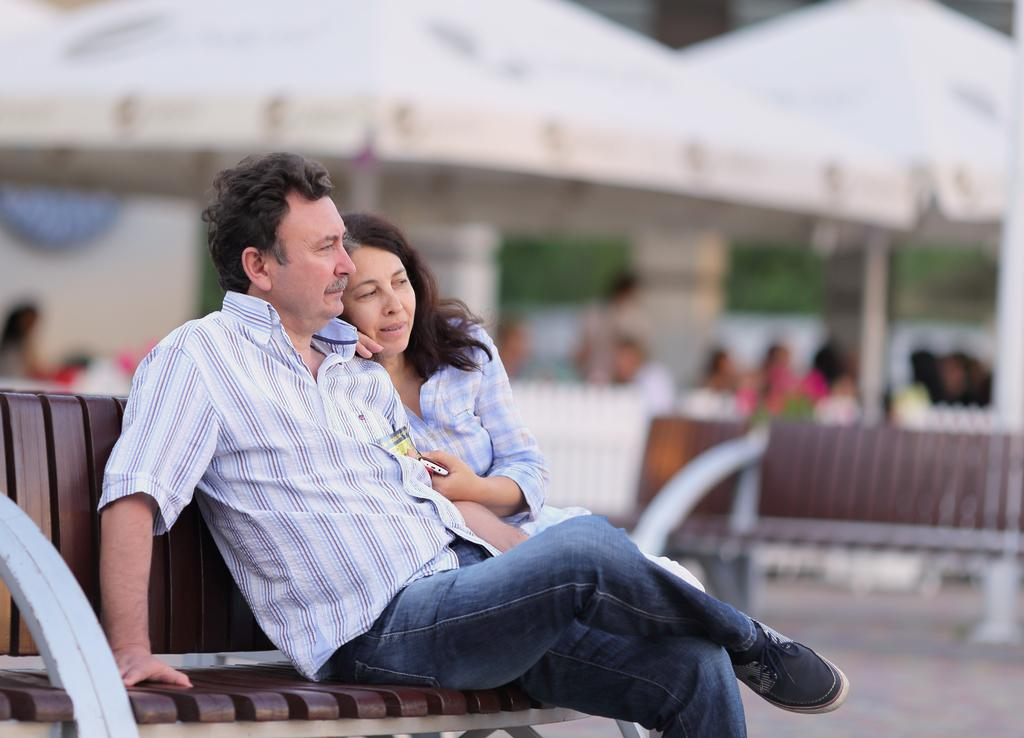Who is present in the image? There is a couple in the image. What are they sitting on? The couple is sitting on a wooden object. Can you describe the background of the image? The background of the image is blurred. What type of fowl can be seen in the image? There is no fowl present in the image. How does the couple slip in the image? The couple is not slipping in the image; they are sitting on a wooden object. 